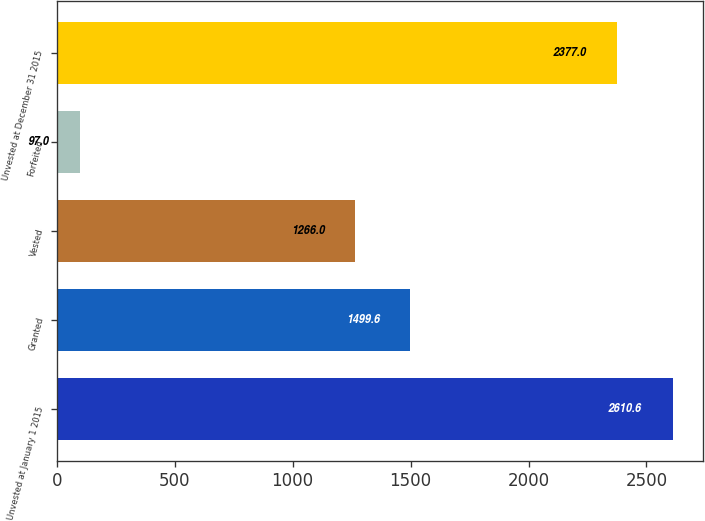Convert chart. <chart><loc_0><loc_0><loc_500><loc_500><bar_chart><fcel>Unvested at January 1 2015<fcel>Granted<fcel>Vested<fcel>Forfeited<fcel>Unvested at December 31 2015<nl><fcel>2610.6<fcel>1499.6<fcel>1266<fcel>97<fcel>2377<nl></chart> 